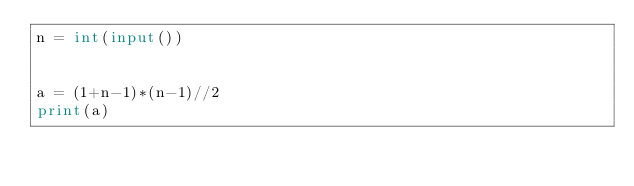Convert code to text. <code><loc_0><loc_0><loc_500><loc_500><_Python_>n = int(input())


a = (1+n-1)*(n-1)//2
print(a)
</code> 